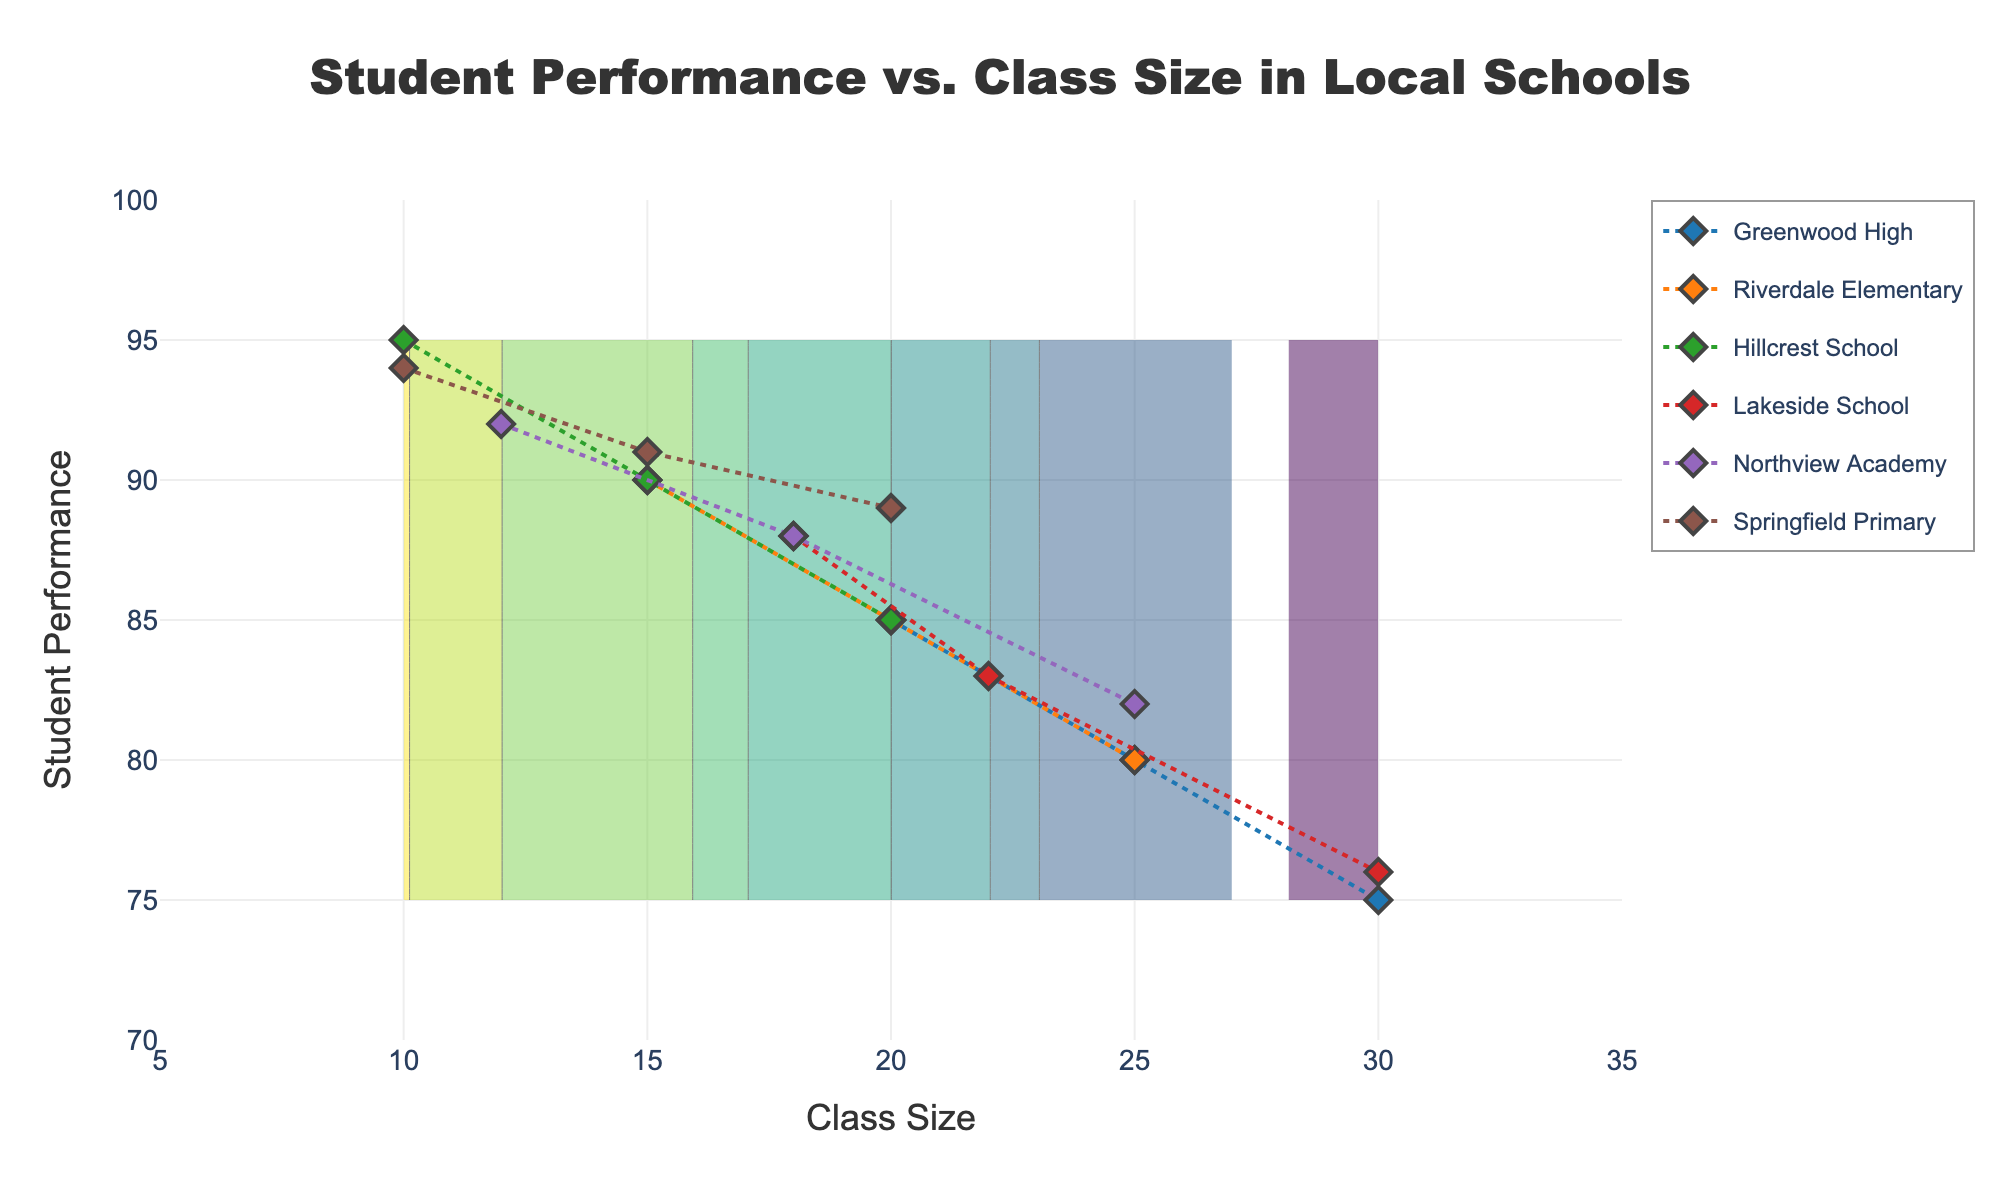What is the title of the plot? The title of the plot is located at the top of the figure. In this plot, it reads, "Student Performance vs. Class Size in Local Schools"
Answer: "Student Performance vs. Class Size in Local Schools" How many schools are represented in the plot? By observing the legend or counting distinct lines/groups, we can see that there are six schools represented in the plot.
Answer: Six What is the range of class sizes displayed on the x-axis? The x-axis represents class sizes and ranges from 5 to 35, based on the label and ticks observed.
Answer: 5 to 35 Which school has the highest student performance at the smallest class size available in the plot? By examining the data points and markers, Hillcrest School exhibits the highest performance at the smallest class size of 10, where its student performance is 95.
Answer: Hillcrest School At what class size does Springfield Primary show a performance of 89? Referencing the data points for Springfield Primary, we see that the performance of 89 occurs at a class size of 20.
Answer: 20 Among all schools, which one exhibits the steepest decline in performance as class size increases from 25 to 30? Analyzing the slopes of the lines for each school between class sizes 25 and 30, Greenwood High shows the steepest decline. Performance drops from 80 to 75.
Answer: Greenwood High Which school maintains the most consistent student performance across varying class sizes? By looking at the graph, Riverdale Elementary has a relatively stable/less steep decline in performance across different class sizes compared to other schools.
Answer: Riverdale Elementary What is the student performance for Northview Academy at a class size of 25? Checking the relevant data points for Northview Academy, the student performance at a class size of 25 is 82.
Answer: 82 How does the class size of 18 compare to the performance levels of different schools? Identifying the intersecting points where class size is 18, we find Northview Academy at 88, Lakeside School at 88, and Springfield Primary at 91.
Answer: Northview Academy: 88, Lakeside School: 88, Springfield Primary: 91 